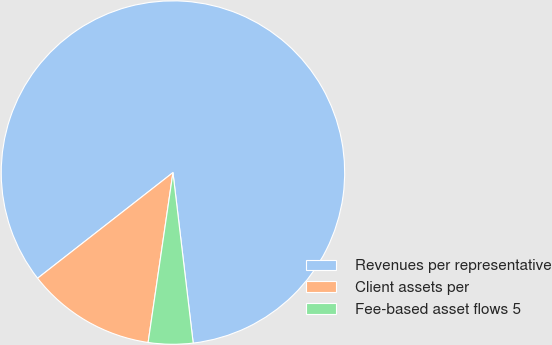Convert chart. <chart><loc_0><loc_0><loc_500><loc_500><pie_chart><fcel>Revenues per representative<fcel>Client assets per<fcel>Fee-based asset flows 5<nl><fcel>83.67%<fcel>12.14%<fcel>4.19%<nl></chart> 